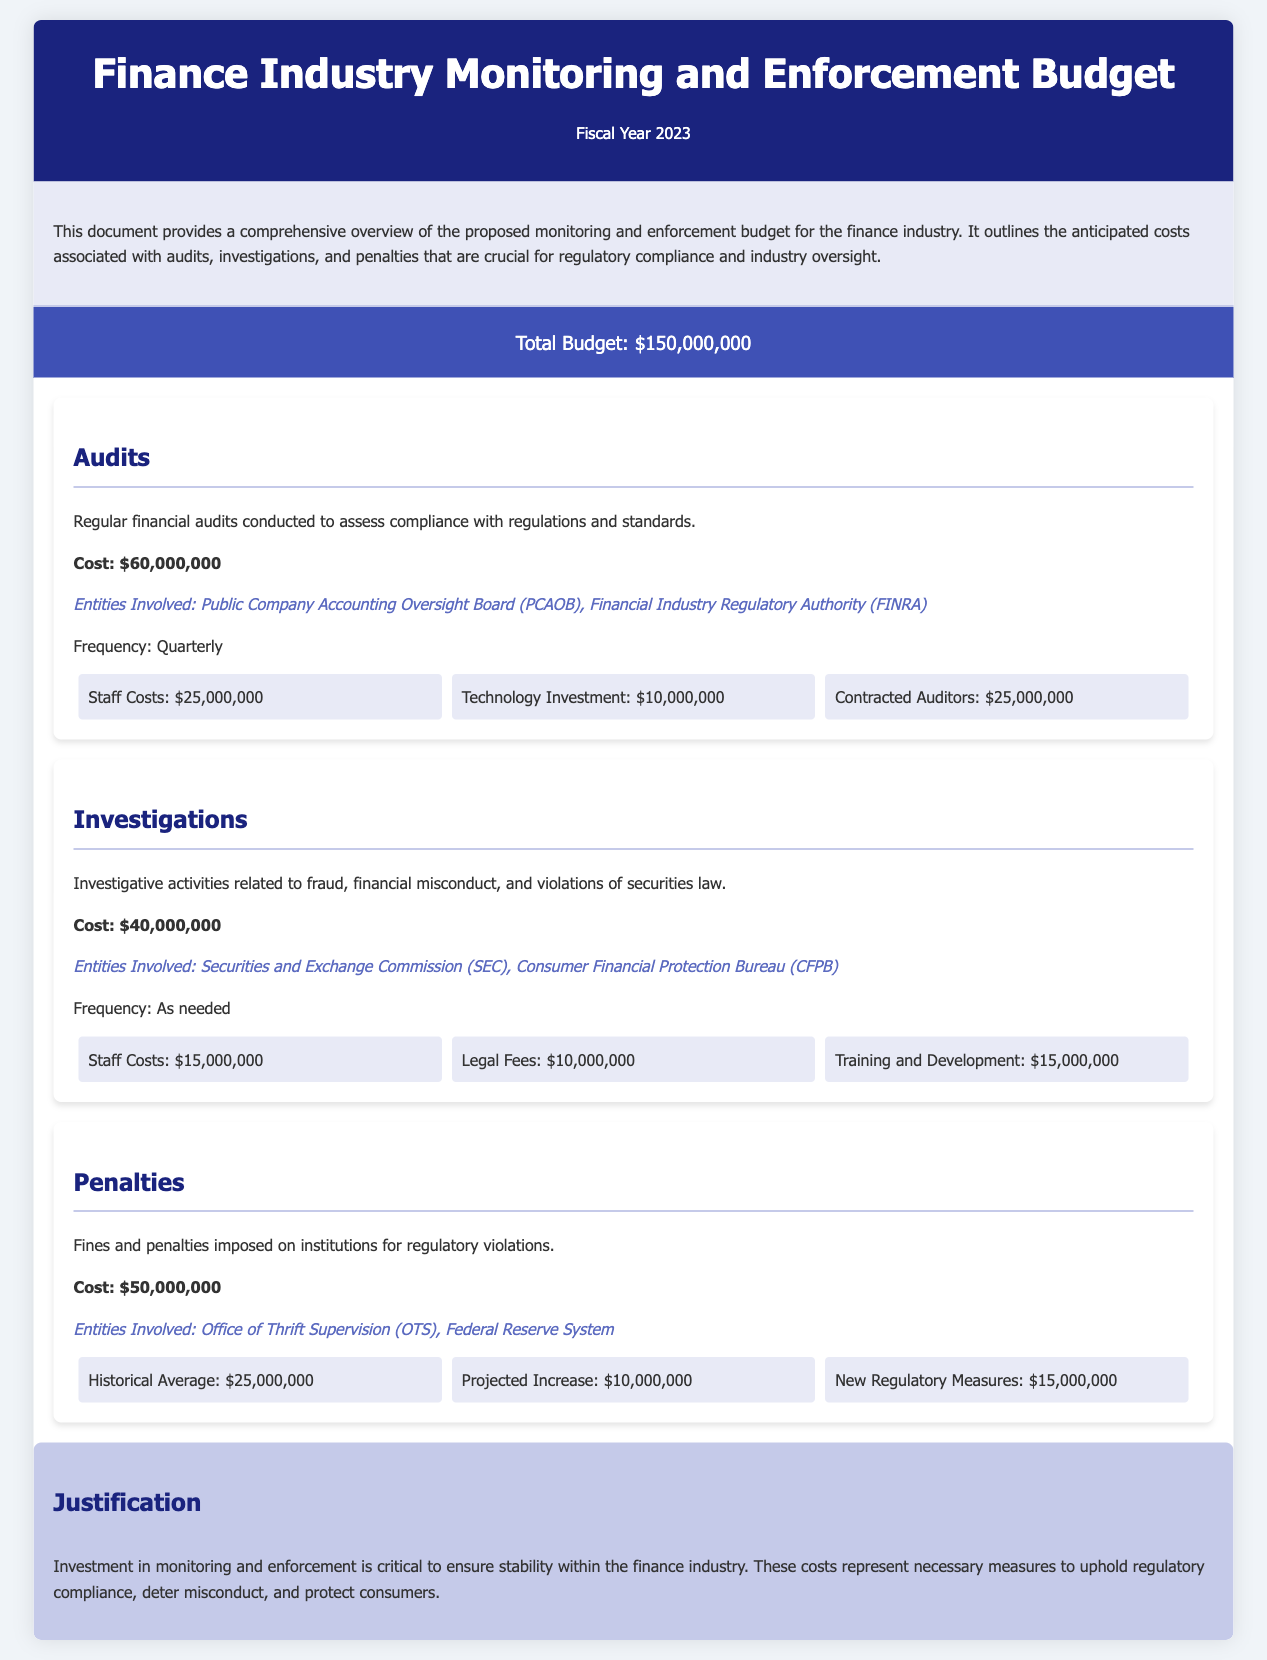What is the total budget for FY 2023? The total budget is explicitly stated in the document as the overall allocation for the finance industry monitoring and enforcement for the fiscal year.
Answer: $150,000,000 What is the cost allocated for audits? The cost for audits is detailed under the audits section, indicating how much will be spent specifically for this category.
Answer: $60,000,000 Who are the entities involved in investigations? The document lists the entities related to investigations, providing the specific organizations responsible for overseeing this area.
Answer: Securities and Exchange Commission (SEC), Consumer Financial Protection Bureau (CFPB) What is the frequency of the audits conducted? The document specifies how often audits are performed, providing insight into the regularity of these assessments.
Answer: Quarterly What are the total staff costs for investigations? Analyzing the break-up of costs for investigations reveals the specific expenses attributed to staff-related activities.
Answer: $15,000,000 What is the projected increase associated with penalties? The document itemizes the cost categories for penalties, including what is expected as an increase from past averages.
Answer: $10,000,000 What is the total cost for penalties? The penalties section provides a summed amount that will be allocated for fines and penalties throughout the fiscal year.
Answer: $50,000,000 What justification is provided for the monitoring and enforcement investment? The justification section summarizes the reasons behind the budget allocation for monitoring and enforcement efforts within the industry.
Answer: Ensure stability within the finance industry What type of activities do the audits focus on? The document defines the purpose of audits, indicating what they are specifically aimed at evaluating.
Answer: Compliance with regulations and standards 